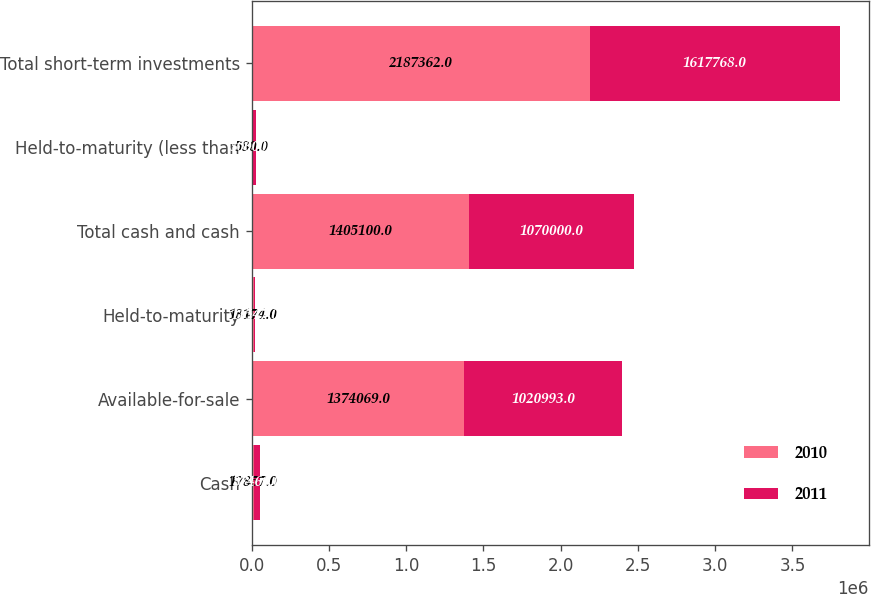<chart> <loc_0><loc_0><loc_500><loc_500><stacked_bar_chart><ecel><fcel>Cash<fcel>Available-for-sale<fcel>Held-to-maturity<fcel>Total cash and cash<fcel>Held-to-maturity (less than<fcel>Total short-term investments<nl><fcel>2010<fcel>17857<fcel>1.37407e+06<fcel>13174<fcel>1.4051e+06<fcel>580<fcel>2.18736e+06<nl><fcel>2011<fcel>37460<fcel>1.02099e+06<fcel>11547<fcel>1.07e+06<fcel>30000<fcel>1.61777e+06<nl></chart> 